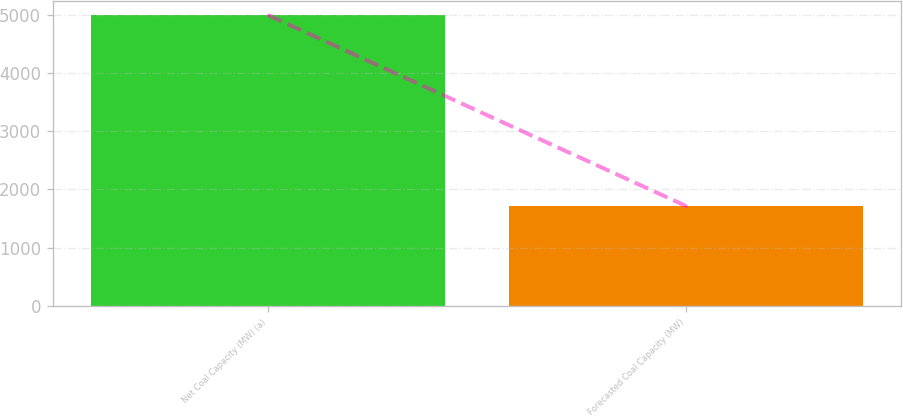Convert chart to OTSL. <chart><loc_0><loc_0><loc_500><loc_500><bar_chart><fcel>Net Coal Capacity (MW) (a)<fcel>Forecasted Coal Capacity (MW)<nl><fcel>4992<fcel>1718<nl></chart> 